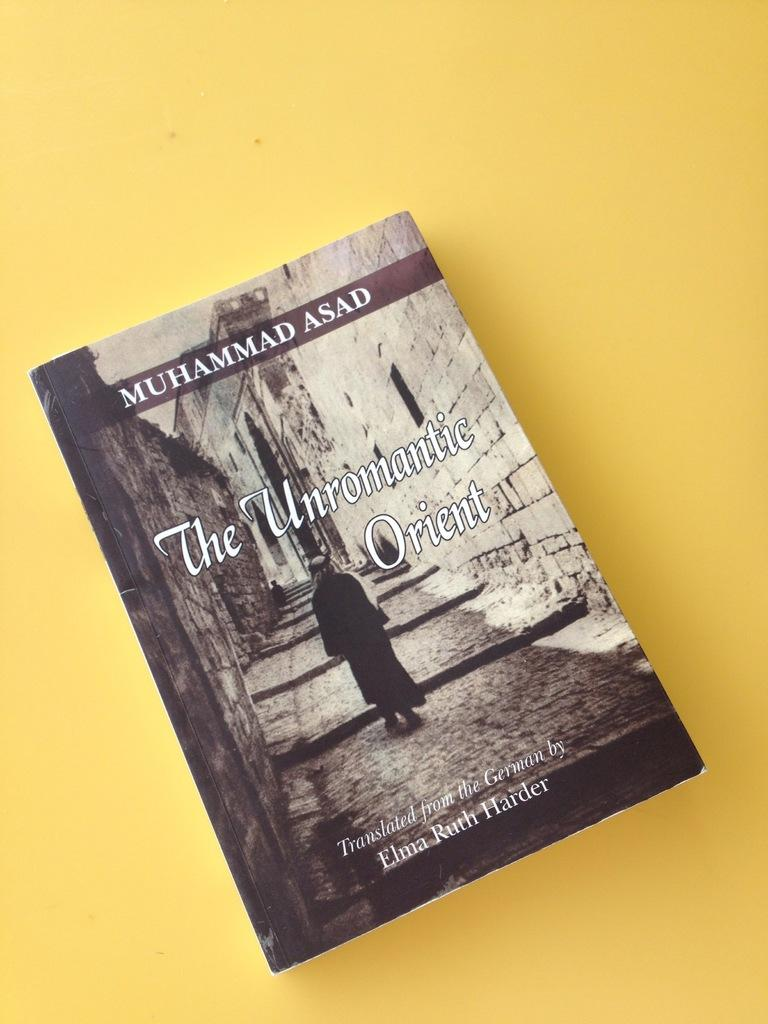<image>
Present a compact description of the photo's key features. The Unromantic Orient was translated by Elma Ruth Harder. 